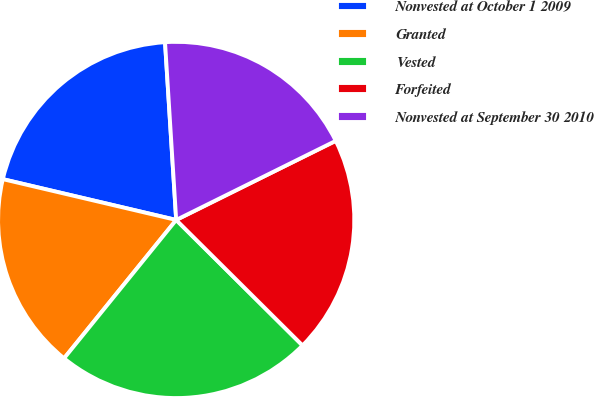<chart> <loc_0><loc_0><loc_500><loc_500><pie_chart><fcel>Nonvested at October 1 2009<fcel>Granted<fcel>Vested<fcel>Forfeited<fcel>Nonvested at September 30 2010<nl><fcel>20.32%<fcel>17.84%<fcel>23.39%<fcel>19.77%<fcel>18.67%<nl></chart> 